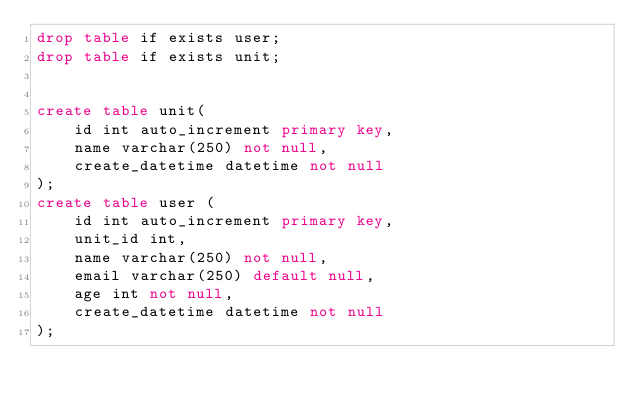Convert code to text. <code><loc_0><loc_0><loc_500><loc_500><_SQL_>drop table if exists user;
drop table if exists unit;


create table unit(
	id int auto_increment primary key,
	name varchar(250) not null,
	create_datetime datetime not null
);
create table user (
	id int auto_increment primary key,
	unit_id int,
	name varchar(250) not null,
	email varchar(250) default null,
	age int not null,
	create_datetime datetime not null
);</code> 